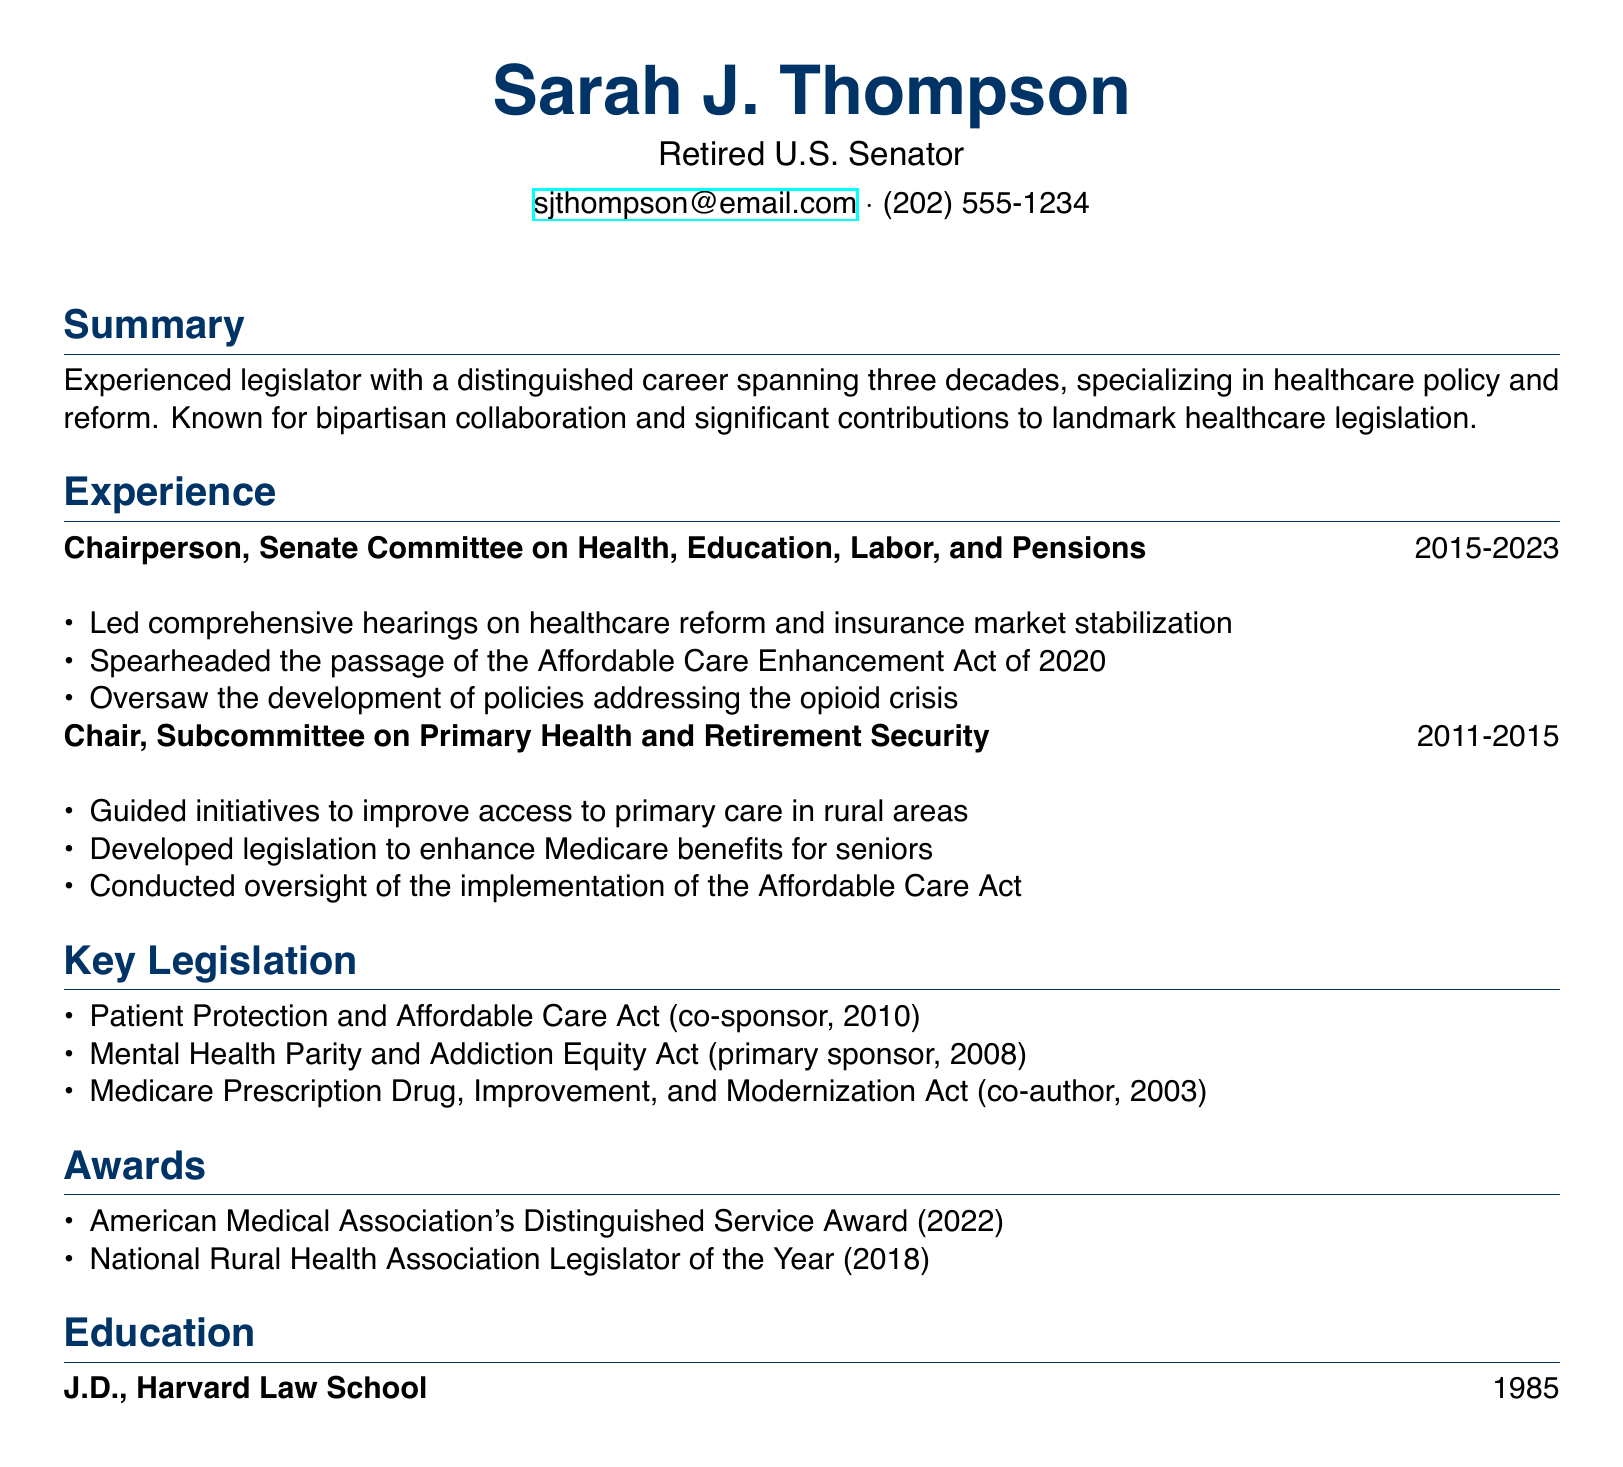what is the name of the retired senator? The name of the retired senator is listed at the top of the document.
Answer: Sarah J. Thompson what position did Sarah J. Thompson hold from 2015 to 2023? This position is noted in the experience section, specifically detailing her role during that period.
Answer: Chairperson, Senate Committee on Health, Education, Labor, and Pensions what notable legislation did Sarah J. Thompson spearhead in 2020? The document directly lists it under her responsibilities in the relevant experience section.
Answer: Affordable Care Enhancement Act how many years did Sarah J. Thompson chair the Subcommittee on Primary Health and Retirement Security? The duration of her chairing this subcommittee is indicated in the experience section.
Answer: 4 years which award did Sarah J. Thompson receive in 2022? Awards received are specifically mentioned in the document.
Answer: American Medical Association's Distinguished Service Award what degree does Sarah J. Thompson hold? The education section provides information on her academic qualification.
Answer: J.D how many key pieces of legislation are listed in the document? A count of the items in the key legislation section gives this information.
Answer: 3 which organization recognized her as Legislator of the Year? This is mentioned in the awards section of the document.
Answer: National Rural Health Association what was a key focus of the Subcommittee she chaired? This can be found by referring to the listed responsibilities when she chaired that subcommittee.
Answer: Access to primary care in rural areas 